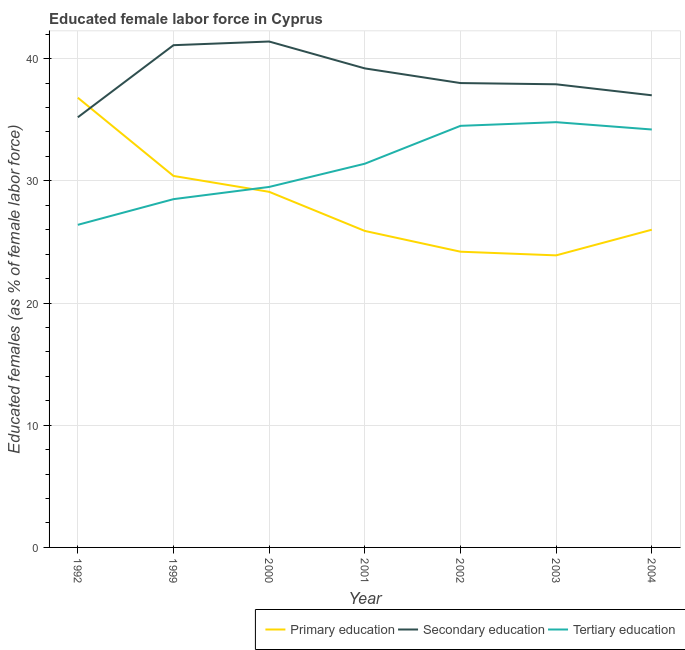How many different coloured lines are there?
Offer a terse response. 3. Does the line corresponding to percentage of female labor force who received secondary education intersect with the line corresponding to percentage of female labor force who received primary education?
Your answer should be very brief. Yes. Is the number of lines equal to the number of legend labels?
Keep it short and to the point. Yes. What is the percentage of female labor force who received secondary education in 2003?
Your answer should be very brief. 37.9. Across all years, what is the maximum percentage of female labor force who received primary education?
Your answer should be very brief. 36.8. Across all years, what is the minimum percentage of female labor force who received secondary education?
Provide a short and direct response. 35.2. In which year was the percentage of female labor force who received tertiary education maximum?
Give a very brief answer. 2003. In which year was the percentage of female labor force who received primary education minimum?
Make the answer very short. 2003. What is the total percentage of female labor force who received tertiary education in the graph?
Make the answer very short. 219.3. What is the difference between the percentage of female labor force who received primary education in 2001 and that in 2004?
Ensure brevity in your answer.  -0.1. What is the difference between the percentage of female labor force who received primary education in 2003 and the percentage of female labor force who received tertiary education in 2000?
Keep it short and to the point. -5.6. What is the average percentage of female labor force who received tertiary education per year?
Your answer should be compact. 31.33. In the year 2001, what is the difference between the percentage of female labor force who received primary education and percentage of female labor force who received secondary education?
Your answer should be very brief. -13.3. What is the ratio of the percentage of female labor force who received secondary education in 1992 to that in 2001?
Your answer should be very brief. 0.9. What is the difference between the highest and the second highest percentage of female labor force who received primary education?
Offer a very short reply. 6.4. What is the difference between the highest and the lowest percentage of female labor force who received secondary education?
Offer a terse response. 6.2. Is the sum of the percentage of female labor force who received secondary education in 2001 and 2002 greater than the maximum percentage of female labor force who received tertiary education across all years?
Make the answer very short. Yes. Is it the case that in every year, the sum of the percentage of female labor force who received primary education and percentage of female labor force who received secondary education is greater than the percentage of female labor force who received tertiary education?
Give a very brief answer. Yes. Is the percentage of female labor force who received secondary education strictly greater than the percentage of female labor force who received tertiary education over the years?
Provide a succinct answer. Yes. Is the percentage of female labor force who received secondary education strictly less than the percentage of female labor force who received primary education over the years?
Provide a succinct answer. No. Are the values on the major ticks of Y-axis written in scientific E-notation?
Ensure brevity in your answer.  No. Does the graph contain any zero values?
Your answer should be compact. No. Where does the legend appear in the graph?
Your answer should be very brief. Bottom right. What is the title of the graph?
Your answer should be very brief. Educated female labor force in Cyprus. Does "Renewable sources" appear as one of the legend labels in the graph?
Offer a terse response. No. What is the label or title of the Y-axis?
Provide a succinct answer. Educated females (as % of female labor force). What is the Educated females (as % of female labor force) in Primary education in 1992?
Ensure brevity in your answer.  36.8. What is the Educated females (as % of female labor force) in Secondary education in 1992?
Give a very brief answer. 35.2. What is the Educated females (as % of female labor force) of Tertiary education in 1992?
Your answer should be compact. 26.4. What is the Educated females (as % of female labor force) in Primary education in 1999?
Give a very brief answer. 30.4. What is the Educated females (as % of female labor force) of Secondary education in 1999?
Provide a short and direct response. 41.1. What is the Educated females (as % of female labor force) in Primary education in 2000?
Your answer should be very brief. 29.1. What is the Educated females (as % of female labor force) of Secondary education in 2000?
Give a very brief answer. 41.4. What is the Educated females (as % of female labor force) in Tertiary education in 2000?
Ensure brevity in your answer.  29.5. What is the Educated females (as % of female labor force) of Primary education in 2001?
Make the answer very short. 25.9. What is the Educated females (as % of female labor force) in Secondary education in 2001?
Offer a very short reply. 39.2. What is the Educated females (as % of female labor force) in Tertiary education in 2001?
Offer a very short reply. 31.4. What is the Educated females (as % of female labor force) in Primary education in 2002?
Offer a terse response. 24.2. What is the Educated females (as % of female labor force) in Secondary education in 2002?
Keep it short and to the point. 38. What is the Educated females (as % of female labor force) in Tertiary education in 2002?
Provide a succinct answer. 34.5. What is the Educated females (as % of female labor force) in Primary education in 2003?
Your answer should be compact. 23.9. What is the Educated females (as % of female labor force) of Secondary education in 2003?
Your answer should be compact. 37.9. What is the Educated females (as % of female labor force) of Tertiary education in 2003?
Provide a short and direct response. 34.8. What is the Educated females (as % of female labor force) in Secondary education in 2004?
Your answer should be compact. 37. What is the Educated females (as % of female labor force) in Tertiary education in 2004?
Provide a succinct answer. 34.2. Across all years, what is the maximum Educated females (as % of female labor force) in Primary education?
Offer a very short reply. 36.8. Across all years, what is the maximum Educated females (as % of female labor force) in Secondary education?
Offer a terse response. 41.4. Across all years, what is the maximum Educated females (as % of female labor force) of Tertiary education?
Offer a terse response. 34.8. Across all years, what is the minimum Educated females (as % of female labor force) in Primary education?
Make the answer very short. 23.9. Across all years, what is the minimum Educated females (as % of female labor force) of Secondary education?
Give a very brief answer. 35.2. Across all years, what is the minimum Educated females (as % of female labor force) of Tertiary education?
Ensure brevity in your answer.  26.4. What is the total Educated females (as % of female labor force) in Primary education in the graph?
Ensure brevity in your answer.  196.3. What is the total Educated females (as % of female labor force) of Secondary education in the graph?
Offer a terse response. 269.8. What is the total Educated females (as % of female labor force) in Tertiary education in the graph?
Your answer should be very brief. 219.3. What is the difference between the Educated females (as % of female labor force) of Secondary education in 1992 and that in 1999?
Your answer should be very brief. -5.9. What is the difference between the Educated females (as % of female labor force) in Tertiary education in 1992 and that in 1999?
Provide a short and direct response. -2.1. What is the difference between the Educated females (as % of female labor force) of Primary education in 1992 and that in 2000?
Make the answer very short. 7.7. What is the difference between the Educated females (as % of female labor force) of Secondary education in 1992 and that in 2000?
Provide a short and direct response. -6.2. What is the difference between the Educated females (as % of female labor force) in Tertiary education in 1992 and that in 2000?
Offer a terse response. -3.1. What is the difference between the Educated females (as % of female labor force) of Primary education in 1992 and that in 2001?
Offer a terse response. 10.9. What is the difference between the Educated females (as % of female labor force) in Tertiary education in 1992 and that in 2001?
Your answer should be compact. -5. What is the difference between the Educated females (as % of female labor force) of Primary education in 1992 and that in 2002?
Offer a very short reply. 12.6. What is the difference between the Educated females (as % of female labor force) in Tertiary education in 1992 and that in 2003?
Keep it short and to the point. -8.4. What is the difference between the Educated females (as % of female labor force) of Primary education in 1992 and that in 2004?
Give a very brief answer. 10.8. What is the difference between the Educated females (as % of female labor force) of Secondary education in 1992 and that in 2004?
Provide a succinct answer. -1.8. What is the difference between the Educated females (as % of female labor force) in Tertiary education in 1992 and that in 2004?
Keep it short and to the point. -7.8. What is the difference between the Educated females (as % of female labor force) in Secondary education in 1999 and that in 2000?
Your answer should be very brief. -0.3. What is the difference between the Educated females (as % of female labor force) in Tertiary education in 1999 and that in 2000?
Provide a succinct answer. -1. What is the difference between the Educated females (as % of female labor force) of Primary education in 1999 and that in 2001?
Ensure brevity in your answer.  4.5. What is the difference between the Educated females (as % of female labor force) in Secondary education in 1999 and that in 2001?
Your response must be concise. 1.9. What is the difference between the Educated females (as % of female labor force) of Primary education in 1999 and that in 2002?
Offer a terse response. 6.2. What is the difference between the Educated females (as % of female labor force) of Secondary education in 1999 and that in 2003?
Provide a succinct answer. 3.2. What is the difference between the Educated females (as % of female labor force) in Primary education in 1999 and that in 2004?
Keep it short and to the point. 4.4. What is the difference between the Educated females (as % of female labor force) of Secondary education in 1999 and that in 2004?
Offer a very short reply. 4.1. What is the difference between the Educated females (as % of female labor force) in Secondary education in 2000 and that in 2001?
Your response must be concise. 2.2. What is the difference between the Educated females (as % of female labor force) of Tertiary education in 2000 and that in 2001?
Ensure brevity in your answer.  -1.9. What is the difference between the Educated females (as % of female labor force) of Tertiary education in 2000 and that in 2004?
Your response must be concise. -4.7. What is the difference between the Educated females (as % of female labor force) in Primary education in 2001 and that in 2002?
Ensure brevity in your answer.  1.7. What is the difference between the Educated females (as % of female labor force) of Primary education in 2001 and that in 2004?
Offer a very short reply. -0.1. What is the difference between the Educated females (as % of female labor force) in Secondary education in 2001 and that in 2004?
Your response must be concise. 2.2. What is the difference between the Educated females (as % of female labor force) in Primary education in 2002 and that in 2003?
Offer a terse response. 0.3. What is the difference between the Educated females (as % of female labor force) in Tertiary education in 2002 and that in 2003?
Give a very brief answer. -0.3. What is the difference between the Educated females (as % of female labor force) in Secondary education in 2002 and that in 2004?
Provide a succinct answer. 1. What is the difference between the Educated females (as % of female labor force) in Primary education in 2003 and that in 2004?
Ensure brevity in your answer.  -2.1. What is the difference between the Educated females (as % of female labor force) of Secondary education in 1992 and the Educated females (as % of female labor force) of Tertiary education in 1999?
Ensure brevity in your answer.  6.7. What is the difference between the Educated females (as % of female labor force) of Primary education in 1992 and the Educated females (as % of female labor force) of Secondary education in 2000?
Your answer should be compact. -4.6. What is the difference between the Educated females (as % of female labor force) in Primary education in 1992 and the Educated females (as % of female labor force) in Tertiary education in 2000?
Offer a very short reply. 7.3. What is the difference between the Educated females (as % of female labor force) in Secondary education in 1992 and the Educated females (as % of female labor force) in Tertiary education in 2000?
Your response must be concise. 5.7. What is the difference between the Educated females (as % of female labor force) in Primary education in 1992 and the Educated females (as % of female labor force) in Tertiary education in 2002?
Your response must be concise. 2.3. What is the difference between the Educated females (as % of female labor force) in Secondary education in 1992 and the Educated females (as % of female labor force) in Tertiary education in 2002?
Provide a succinct answer. 0.7. What is the difference between the Educated females (as % of female labor force) of Primary education in 1992 and the Educated females (as % of female labor force) of Secondary education in 2004?
Provide a short and direct response. -0.2. What is the difference between the Educated females (as % of female labor force) in Primary education in 1992 and the Educated females (as % of female labor force) in Tertiary education in 2004?
Give a very brief answer. 2.6. What is the difference between the Educated females (as % of female labor force) in Primary education in 1999 and the Educated females (as % of female labor force) in Secondary education in 2000?
Offer a terse response. -11. What is the difference between the Educated females (as % of female labor force) of Secondary education in 1999 and the Educated females (as % of female labor force) of Tertiary education in 2001?
Your answer should be very brief. 9.7. What is the difference between the Educated females (as % of female labor force) in Secondary education in 1999 and the Educated females (as % of female labor force) in Tertiary education in 2002?
Ensure brevity in your answer.  6.6. What is the difference between the Educated females (as % of female labor force) in Secondary education in 1999 and the Educated females (as % of female labor force) in Tertiary education in 2003?
Your answer should be compact. 6.3. What is the difference between the Educated females (as % of female labor force) of Primary education in 1999 and the Educated females (as % of female labor force) of Secondary education in 2004?
Give a very brief answer. -6.6. What is the difference between the Educated females (as % of female labor force) of Secondary education in 1999 and the Educated females (as % of female labor force) of Tertiary education in 2004?
Give a very brief answer. 6.9. What is the difference between the Educated females (as % of female labor force) of Primary education in 2000 and the Educated females (as % of female labor force) of Tertiary education in 2001?
Keep it short and to the point. -2.3. What is the difference between the Educated females (as % of female labor force) of Primary education in 2000 and the Educated females (as % of female labor force) of Secondary education in 2002?
Offer a very short reply. -8.9. What is the difference between the Educated females (as % of female labor force) in Secondary education in 2001 and the Educated females (as % of female labor force) in Tertiary education in 2002?
Your answer should be compact. 4.7. What is the difference between the Educated females (as % of female labor force) in Primary education in 2001 and the Educated females (as % of female labor force) in Secondary education in 2003?
Make the answer very short. -12. What is the difference between the Educated females (as % of female labor force) in Primary education in 2001 and the Educated females (as % of female labor force) in Tertiary education in 2004?
Offer a terse response. -8.3. What is the difference between the Educated females (as % of female labor force) in Secondary education in 2001 and the Educated females (as % of female labor force) in Tertiary education in 2004?
Your answer should be very brief. 5. What is the difference between the Educated females (as % of female labor force) in Primary education in 2002 and the Educated females (as % of female labor force) in Secondary education in 2003?
Offer a very short reply. -13.7. What is the difference between the Educated females (as % of female labor force) in Primary education in 2002 and the Educated females (as % of female labor force) in Tertiary education in 2003?
Offer a very short reply. -10.6. What is the difference between the Educated females (as % of female labor force) of Primary education in 2002 and the Educated females (as % of female labor force) of Secondary education in 2004?
Offer a very short reply. -12.8. What is the difference between the Educated females (as % of female labor force) in Primary education in 2002 and the Educated females (as % of female labor force) in Tertiary education in 2004?
Your answer should be compact. -10. What is the difference between the Educated females (as % of female labor force) of Secondary education in 2002 and the Educated females (as % of female labor force) of Tertiary education in 2004?
Ensure brevity in your answer.  3.8. What is the average Educated females (as % of female labor force) of Primary education per year?
Ensure brevity in your answer.  28.04. What is the average Educated females (as % of female labor force) in Secondary education per year?
Make the answer very short. 38.54. What is the average Educated females (as % of female labor force) in Tertiary education per year?
Offer a very short reply. 31.33. In the year 1992, what is the difference between the Educated females (as % of female labor force) in Primary education and Educated females (as % of female labor force) in Tertiary education?
Offer a terse response. 10.4. In the year 1999, what is the difference between the Educated females (as % of female labor force) in Primary education and Educated females (as % of female labor force) in Secondary education?
Keep it short and to the point. -10.7. In the year 2000, what is the difference between the Educated females (as % of female labor force) in Primary education and Educated females (as % of female labor force) in Tertiary education?
Give a very brief answer. -0.4. In the year 2000, what is the difference between the Educated females (as % of female labor force) in Secondary education and Educated females (as % of female labor force) in Tertiary education?
Provide a short and direct response. 11.9. In the year 2001, what is the difference between the Educated females (as % of female labor force) in Primary education and Educated females (as % of female labor force) in Secondary education?
Your answer should be very brief. -13.3. In the year 2001, what is the difference between the Educated females (as % of female labor force) in Secondary education and Educated females (as % of female labor force) in Tertiary education?
Ensure brevity in your answer.  7.8. In the year 2002, what is the difference between the Educated females (as % of female labor force) of Primary education and Educated females (as % of female labor force) of Secondary education?
Ensure brevity in your answer.  -13.8. In the year 2002, what is the difference between the Educated females (as % of female labor force) of Primary education and Educated females (as % of female labor force) of Tertiary education?
Keep it short and to the point. -10.3. In the year 2002, what is the difference between the Educated females (as % of female labor force) of Secondary education and Educated females (as % of female labor force) of Tertiary education?
Ensure brevity in your answer.  3.5. In the year 2003, what is the difference between the Educated females (as % of female labor force) of Primary education and Educated females (as % of female labor force) of Secondary education?
Provide a short and direct response. -14. In the year 2003, what is the difference between the Educated females (as % of female labor force) of Primary education and Educated females (as % of female labor force) of Tertiary education?
Your answer should be very brief. -10.9. In the year 2003, what is the difference between the Educated females (as % of female labor force) of Secondary education and Educated females (as % of female labor force) of Tertiary education?
Your response must be concise. 3.1. In the year 2004, what is the difference between the Educated females (as % of female labor force) in Primary education and Educated females (as % of female labor force) in Secondary education?
Give a very brief answer. -11. In the year 2004, what is the difference between the Educated females (as % of female labor force) in Primary education and Educated females (as % of female labor force) in Tertiary education?
Make the answer very short. -8.2. What is the ratio of the Educated females (as % of female labor force) of Primary education in 1992 to that in 1999?
Your answer should be compact. 1.21. What is the ratio of the Educated females (as % of female labor force) of Secondary education in 1992 to that in 1999?
Make the answer very short. 0.86. What is the ratio of the Educated females (as % of female labor force) in Tertiary education in 1992 to that in 1999?
Offer a very short reply. 0.93. What is the ratio of the Educated females (as % of female labor force) of Primary education in 1992 to that in 2000?
Ensure brevity in your answer.  1.26. What is the ratio of the Educated females (as % of female labor force) of Secondary education in 1992 to that in 2000?
Provide a short and direct response. 0.85. What is the ratio of the Educated females (as % of female labor force) of Tertiary education in 1992 to that in 2000?
Make the answer very short. 0.89. What is the ratio of the Educated females (as % of female labor force) in Primary education in 1992 to that in 2001?
Offer a terse response. 1.42. What is the ratio of the Educated females (as % of female labor force) of Secondary education in 1992 to that in 2001?
Your answer should be very brief. 0.9. What is the ratio of the Educated females (as % of female labor force) in Tertiary education in 1992 to that in 2001?
Keep it short and to the point. 0.84. What is the ratio of the Educated females (as % of female labor force) in Primary education in 1992 to that in 2002?
Make the answer very short. 1.52. What is the ratio of the Educated females (as % of female labor force) in Secondary education in 1992 to that in 2002?
Ensure brevity in your answer.  0.93. What is the ratio of the Educated females (as % of female labor force) in Tertiary education in 1992 to that in 2002?
Ensure brevity in your answer.  0.77. What is the ratio of the Educated females (as % of female labor force) in Primary education in 1992 to that in 2003?
Provide a succinct answer. 1.54. What is the ratio of the Educated females (as % of female labor force) in Secondary education in 1992 to that in 2003?
Ensure brevity in your answer.  0.93. What is the ratio of the Educated females (as % of female labor force) of Tertiary education in 1992 to that in 2003?
Provide a short and direct response. 0.76. What is the ratio of the Educated females (as % of female labor force) in Primary education in 1992 to that in 2004?
Give a very brief answer. 1.42. What is the ratio of the Educated females (as % of female labor force) in Secondary education in 1992 to that in 2004?
Offer a terse response. 0.95. What is the ratio of the Educated females (as % of female labor force) in Tertiary education in 1992 to that in 2004?
Your response must be concise. 0.77. What is the ratio of the Educated females (as % of female labor force) of Primary education in 1999 to that in 2000?
Provide a succinct answer. 1.04. What is the ratio of the Educated females (as % of female labor force) of Tertiary education in 1999 to that in 2000?
Make the answer very short. 0.97. What is the ratio of the Educated females (as % of female labor force) in Primary education in 1999 to that in 2001?
Ensure brevity in your answer.  1.17. What is the ratio of the Educated females (as % of female labor force) in Secondary education in 1999 to that in 2001?
Your answer should be compact. 1.05. What is the ratio of the Educated females (as % of female labor force) in Tertiary education in 1999 to that in 2001?
Provide a short and direct response. 0.91. What is the ratio of the Educated females (as % of female labor force) in Primary education in 1999 to that in 2002?
Provide a short and direct response. 1.26. What is the ratio of the Educated females (as % of female labor force) in Secondary education in 1999 to that in 2002?
Offer a terse response. 1.08. What is the ratio of the Educated females (as % of female labor force) in Tertiary education in 1999 to that in 2002?
Your answer should be compact. 0.83. What is the ratio of the Educated females (as % of female labor force) in Primary education in 1999 to that in 2003?
Give a very brief answer. 1.27. What is the ratio of the Educated females (as % of female labor force) in Secondary education in 1999 to that in 2003?
Ensure brevity in your answer.  1.08. What is the ratio of the Educated females (as % of female labor force) of Tertiary education in 1999 to that in 2003?
Keep it short and to the point. 0.82. What is the ratio of the Educated females (as % of female labor force) of Primary education in 1999 to that in 2004?
Provide a short and direct response. 1.17. What is the ratio of the Educated females (as % of female labor force) in Secondary education in 1999 to that in 2004?
Give a very brief answer. 1.11. What is the ratio of the Educated females (as % of female labor force) in Primary education in 2000 to that in 2001?
Ensure brevity in your answer.  1.12. What is the ratio of the Educated females (as % of female labor force) in Secondary education in 2000 to that in 2001?
Ensure brevity in your answer.  1.06. What is the ratio of the Educated females (as % of female labor force) in Tertiary education in 2000 to that in 2001?
Your answer should be very brief. 0.94. What is the ratio of the Educated females (as % of female labor force) in Primary education in 2000 to that in 2002?
Make the answer very short. 1.2. What is the ratio of the Educated females (as % of female labor force) in Secondary education in 2000 to that in 2002?
Give a very brief answer. 1.09. What is the ratio of the Educated females (as % of female labor force) in Tertiary education in 2000 to that in 2002?
Provide a short and direct response. 0.86. What is the ratio of the Educated females (as % of female labor force) of Primary education in 2000 to that in 2003?
Offer a terse response. 1.22. What is the ratio of the Educated females (as % of female labor force) of Secondary education in 2000 to that in 2003?
Provide a succinct answer. 1.09. What is the ratio of the Educated females (as % of female labor force) of Tertiary education in 2000 to that in 2003?
Keep it short and to the point. 0.85. What is the ratio of the Educated females (as % of female labor force) in Primary education in 2000 to that in 2004?
Offer a terse response. 1.12. What is the ratio of the Educated females (as % of female labor force) in Secondary education in 2000 to that in 2004?
Offer a very short reply. 1.12. What is the ratio of the Educated females (as % of female labor force) in Tertiary education in 2000 to that in 2004?
Offer a very short reply. 0.86. What is the ratio of the Educated females (as % of female labor force) in Primary education in 2001 to that in 2002?
Provide a short and direct response. 1.07. What is the ratio of the Educated females (as % of female labor force) of Secondary education in 2001 to that in 2002?
Your answer should be compact. 1.03. What is the ratio of the Educated females (as % of female labor force) of Tertiary education in 2001 to that in 2002?
Offer a terse response. 0.91. What is the ratio of the Educated females (as % of female labor force) of Primary education in 2001 to that in 2003?
Offer a very short reply. 1.08. What is the ratio of the Educated females (as % of female labor force) of Secondary education in 2001 to that in 2003?
Provide a short and direct response. 1.03. What is the ratio of the Educated females (as % of female labor force) of Tertiary education in 2001 to that in 2003?
Your answer should be compact. 0.9. What is the ratio of the Educated females (as % of female labor force) in Secondary education in 2001 to that in 2004?
Your answer should be compact. 1.06. What is the ratio of the Educated females (as % of female labor force) of Tertiary education in 2001 to that in 2004?
Make the answer very short. 0.92. What is the ratio of the Educated females (as % of female labor force) in Primary education in 2002 to that in 2003?
Ensure brevity in your answer.  1.01. What is the ratio of the Educated females (as % of female labor force) in Tertiary education in 2002 to that in 2003?
Your answer should be compact. 0.99. What is the ratio of the Educated females (as % of female labor force) of Primary education in 2002 to that in 2004?
Your answer should be very brief. 0.93. What is the ratio of the Educated females (as % of female labor force) in Tertiary education in 2002 to that in 2004?
Provide a short and direct response. 1.01. What is the ratio of the Educated females (as % of female labor force) in Primary education in 2003 to that in 2004?
Make the answer very short. 0.92. What is the ratio of the Educated females (as % of female labor force) of Secondary education in 2003 to that in 2004?
Make the answer very short. 1.02. What is the ratio of the Educated females (as % of female labor force) in Tertiary education in 2003 to that in 2004?
Provide a succinct answer. 1.02. What is the difference between the highest and the second highest Educated females (as % of female labor force) in Primary education?
Your answer should be compact. 6.4. What is the difference between the highest and the second highest Educated females (as % of female labor force) of Secondary education?
Give a very brief answer. 0.3. What is the difference between the highest and the second highest Educated females (as % of female labor force) in Tertiary education?
Your response must be concise. 0.3. 